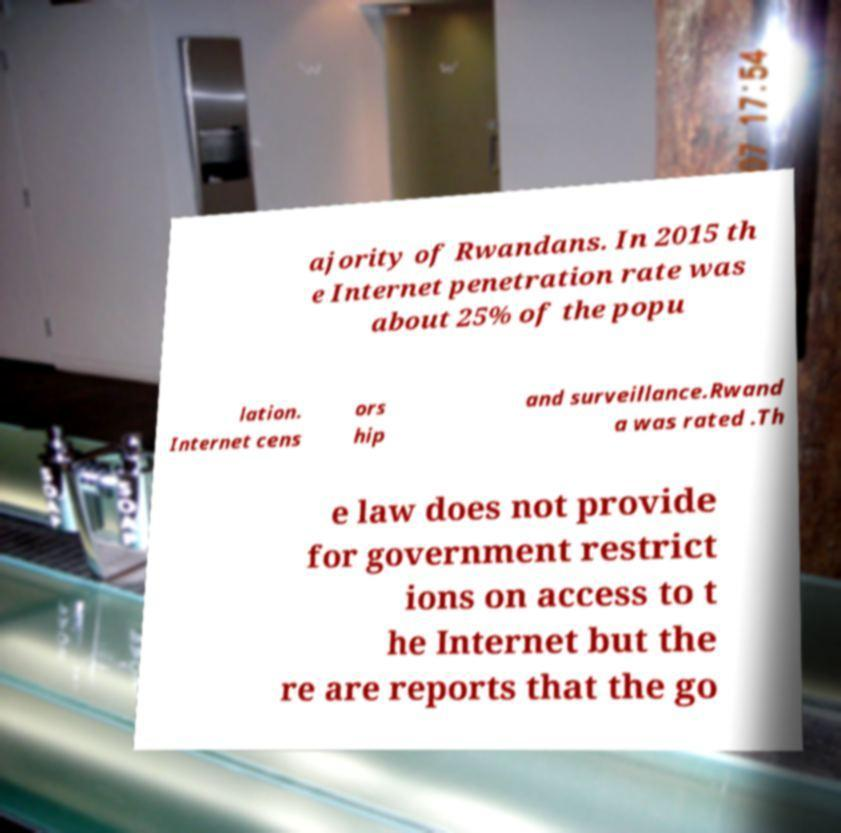For documentation purposes, I need the text within this image transcribed. Could you provide that? ajority of Rwandans. In 2015 th e Internet penetration rate was about 25% of the popu lation. Internet cens ors hip and surveillance.Rwand a was rated .Th e law does not provide for government restrict ions on access to t he Internet but the re are reports that the go 